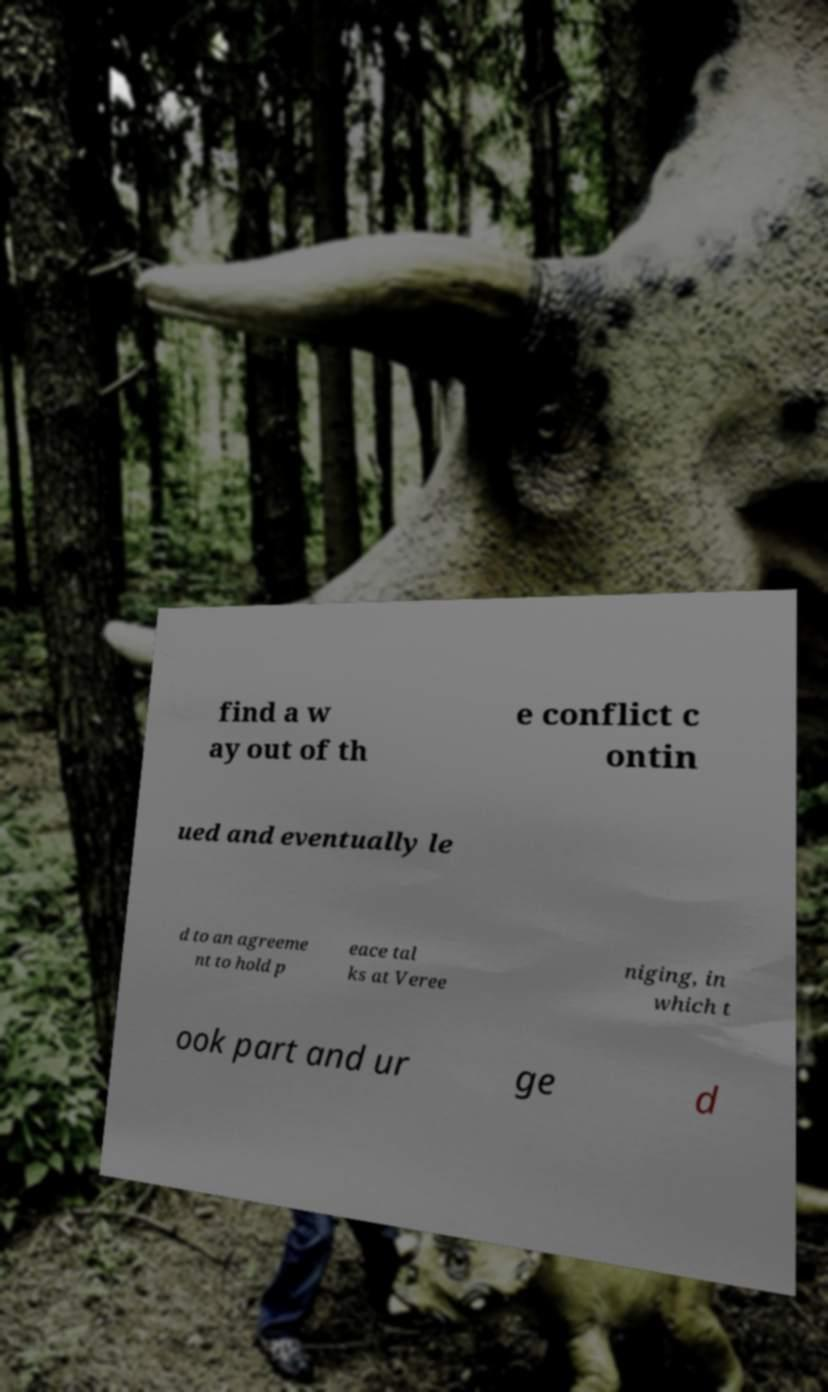Could you assist in decoding the text presented in this image and type it out clearly? find a w ay out of th e conflict c ontin ued and eventually le d to an agreeme nt to hold p eace tal ks at Veree niging, in which t ook part and ur ge d 